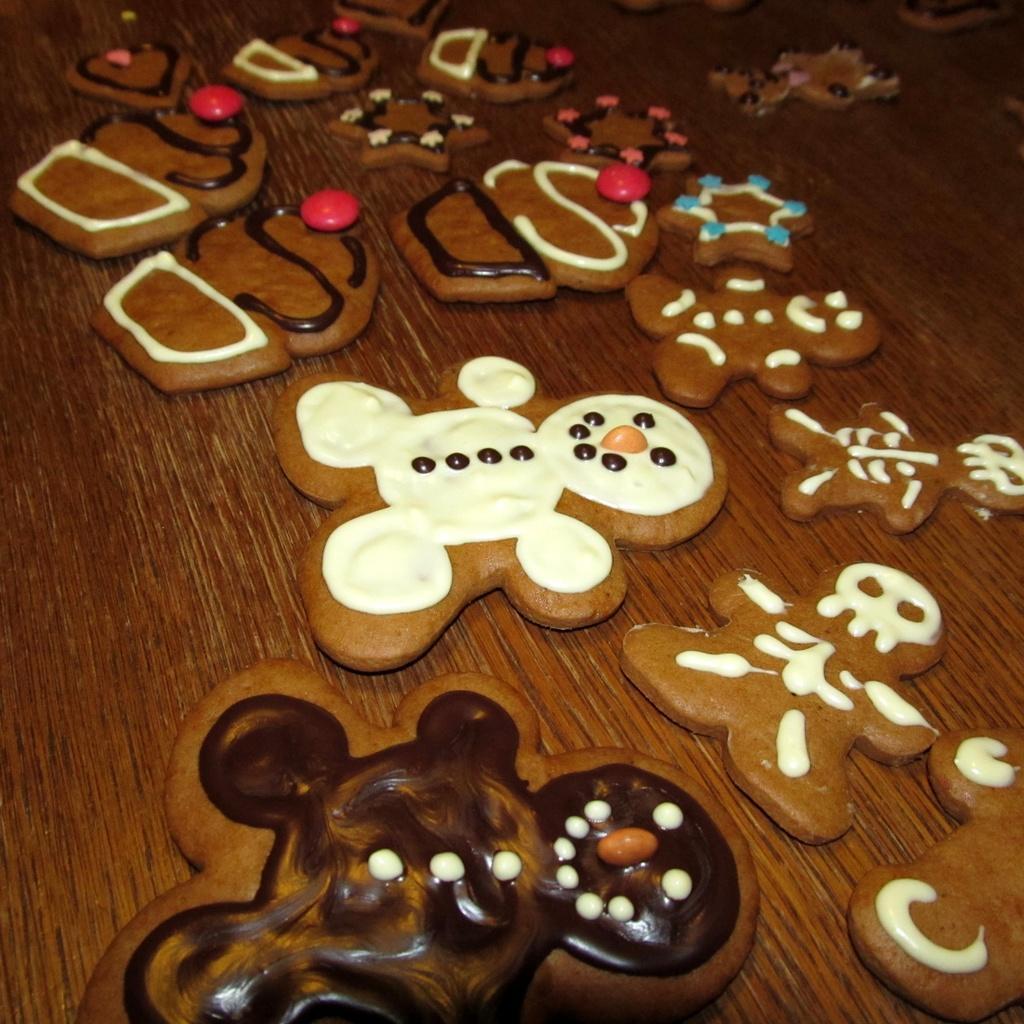In one or two sentences, can you explain what this image depicts? In the foreground of the picture there is a table, on the table there are cookies. 